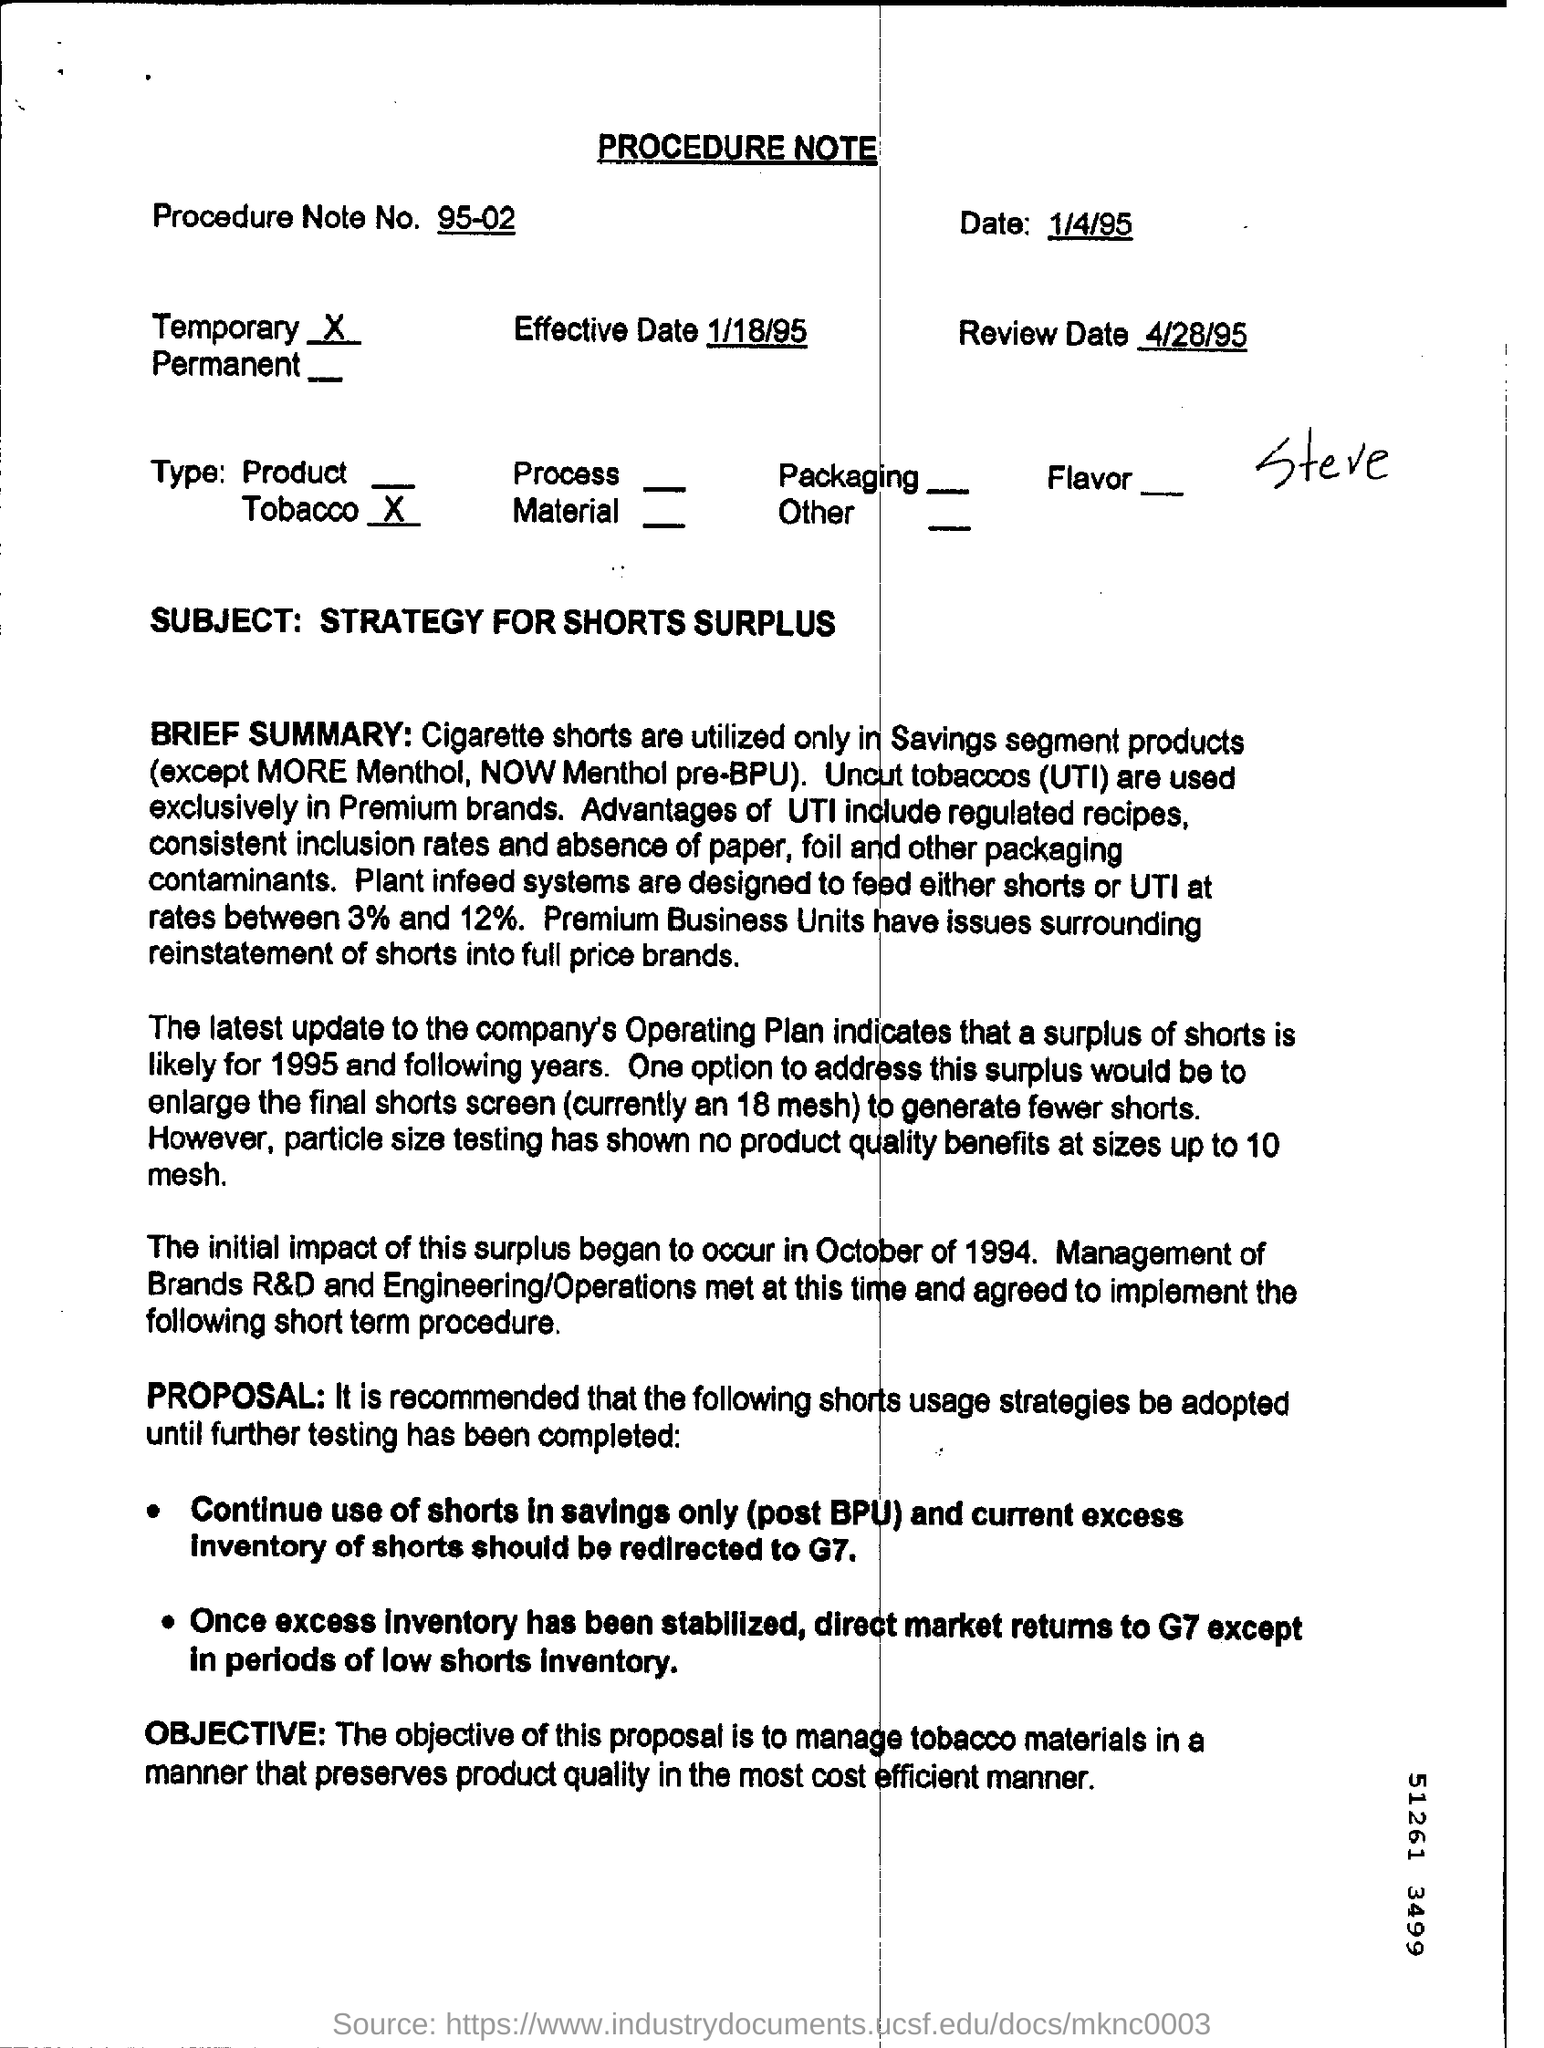What is the review date listed on this procedure note? The review date listed on the procedure note is 4/28/95. 